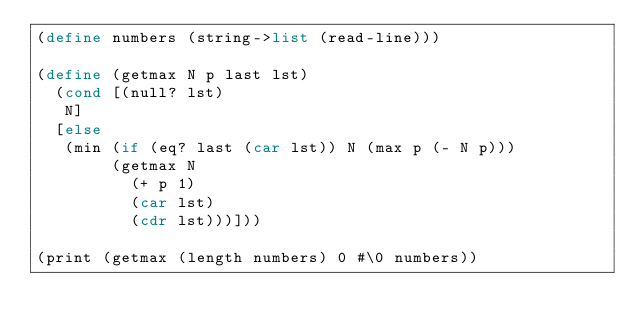<code> <loc_0><loc_0><loc_500><loc_500><_Scheme_>(define numbers (string->list (read-line)))

(define (getmax N p last lst)
  (cond [(null? lst)
	 N]
	[else
	 (min (if (eq? last (car lst)) N (max p (- N p)))
	      (getmax N
		      (+ p 1)
		      (car lst)
		      (cdr lst)))]))

(print (getmax (length numbers) 0 #\0 numbers))
</code> 